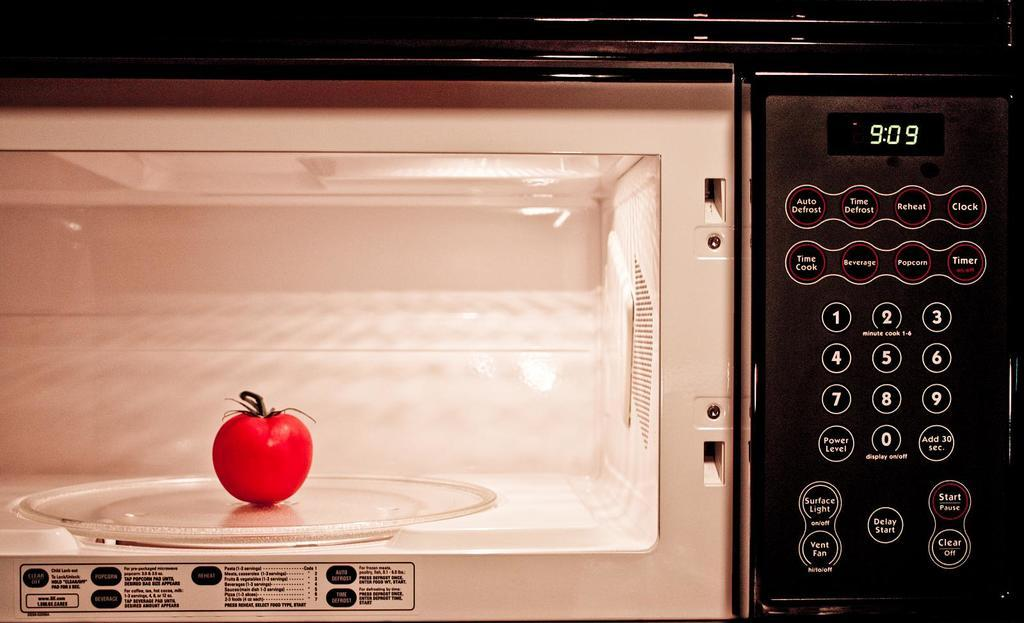<image>
Render a clear and concise summary of the photo. A black microwave that has some functions such as auto defrost and reheat. 